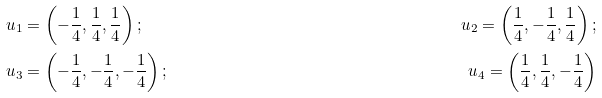<formula> <loc_0><loc_0><loc_500><loc_500>& u _ { 1 } = \left ( - \frac { 1 } { 4 } , \frac { 1 } { 4 } , \frac { 1 } { 4 } \right ) ; & u _ { 2 } = \left ( \frac { 1 } { 4 } , - \frac { 1 } { 4 } , \frac { 1 } { 4 } \right ) ; \\ & u _ { 3 } = \left ( - \frac { 1 } { 4 } , - \frac { 1 } { 4 } , - \frac { 1 } { 4 } \right ) ; & u _ { 4 } = \left ( \frac { 1 } { 4 } , \frac { 1 } { 4 } , - \frac { 1 } { 4 } \right )</formula> 